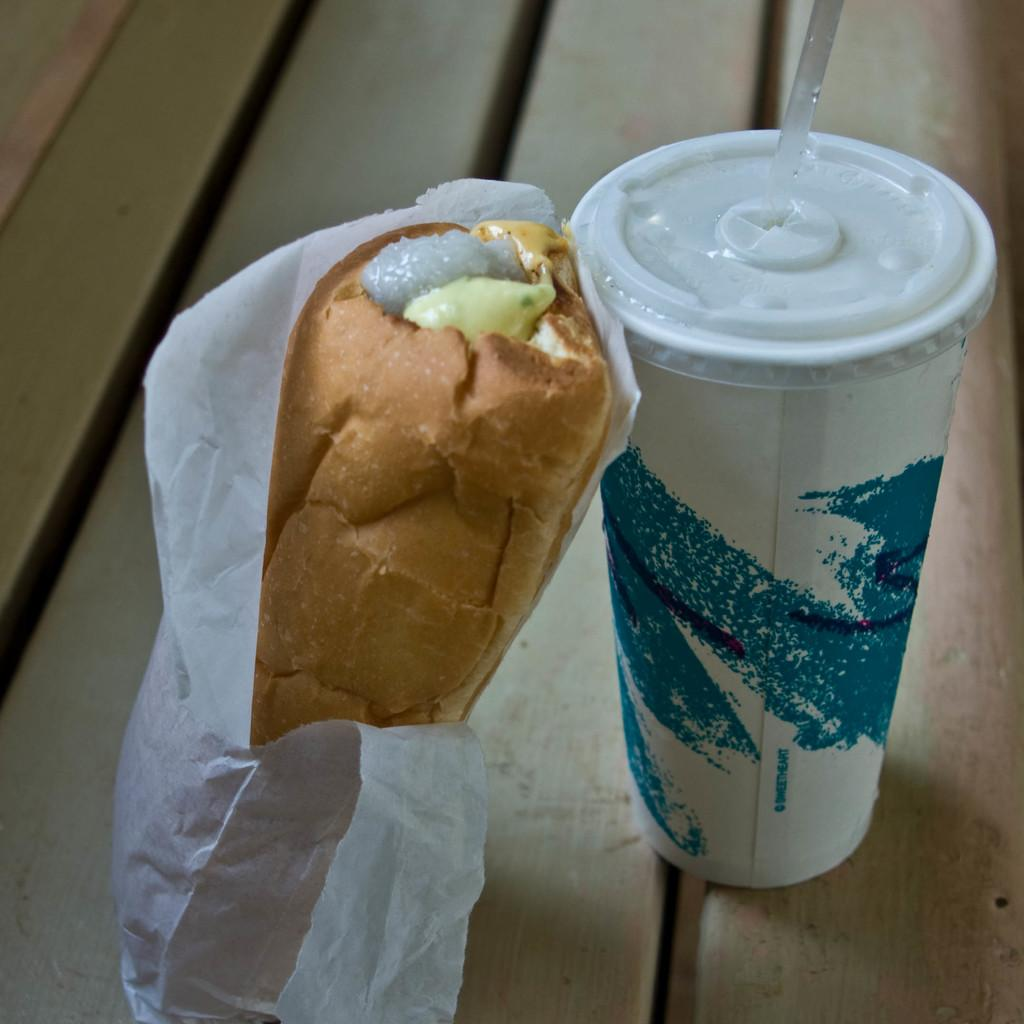What type of food is wrapped in a cover in the image? There is a sandwich wrapped in a cover in the image. What is the drink container in the image? There is a glass with a straw in the image. Where are the sandwich and glass located in the image? The sandwich and glass are on a wooden path in the image. What type of muscle can be seen flexing in the image? There is no muscle visible in the image; it features a sandwich wrapped in a cover and a glass with a straw on a wooden path. 